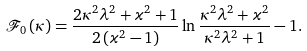Convert formula to latex. <formula><loc_0><loc_0><loc_500><loc_500>\mathcal { F } _ { 0 } \left ( \kappa \right ) = \frac { 2 \kappa ^ { 2 } \lambda ^ { 2 } + \varkappa ^ { 2 } + 1 } { 2 \left ( \varkappa ^ { 2 } - 1 \right ) } \ln \frac { \kappa ^ { 2 } \lambda ^ { 2 } + \varkappa ^ { 2 } } { \kappa ^ { 2 } \lambda ^ { 2 } + 1 } - 1 .</formula> 